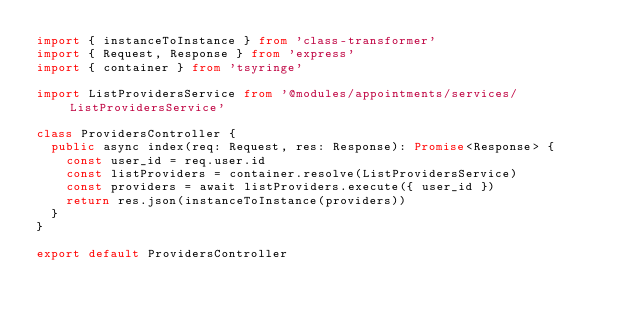<code> <loc_0><loc_0><loc_500><loc_500><_TypeScript_>import { instanceToInstance } from 'class-transformer'
import { Request, Response } from 'express'
import { container } from 'tsyringe'

import ListProvidersService from '@modules/appointments/services/ListProvidersService'

class ProvidersController {
  public async index(req: Request, res: Response): Promise<Response> {
    const user_id = req.user.id
    const listProviders = container.resolve(ListProvidersService)
    const providers = await listProviders.execute({ user_id })
    return res.json(instanceToInstance(providers))
  }
}

export default ProvidersController
</code> 